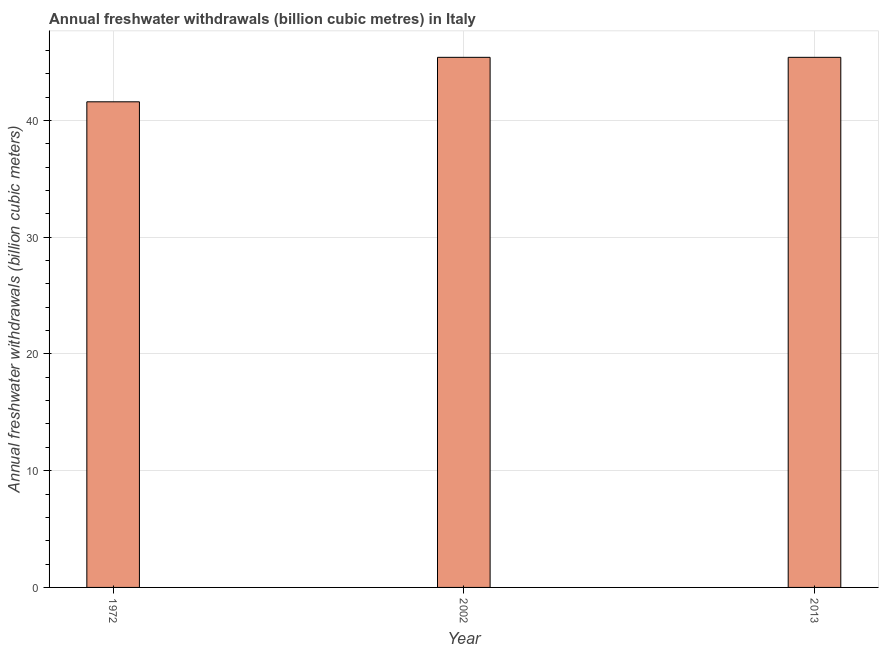What is the title of the graph?
Give a very brief answer. Annual freshwater withdrawals (billion cubic metres) in Italy. What is the label or title of the Y-axis?
Give a very brief answer. Annual freshwater withdrawals (billion cubic meters). What is the annual freshwater withdrawals in 1972?
Ensure brevity in your answer.  41.6. Across all years, what is the maximum annual freshwater withdrawals?
Offer a terse response. 45.41. Across all years, what is the minimum annual freshwater withdrawals?
Give a very brief answer. 41.6. What is the sum of the annual freshwater withdrawals?
Your response must be concise. 132.42. What is the difference between the annual freshwater withdrawals in 1972 and 2013?
Ensure brevity in your answer.  -3.81. What is the average annual freshwater withdrawals per year?
Your answer should be compact. 44.14. What is the median annual freshwater withdrawals?
Provide a succinct answer. 45.41. Do a majority of the years between 2002 and 1972 (inclusive) have annual freshwater withdrawals greater than 30 billion cubic meters?
Ensure brevity in your answer.  No. What is the ratio of the annual freshwater withdrawals in 1972 to that in 2002?
Your answer should be very brief. 0.92. Is the annual freshwater withdrawals in 2002 less than that in 2013?
Your answer should be very brief. No. Is the difference between the annual freshwater withdrawals in 1972 and 2002 greater than the difference between any two years?
Ensure brevity in your answer.  Yes. Is the sum of the annual freshwater withdrawals in 2002 and 2013 greater than the maximum annual freshwater withdrawals across all years?
Offer a very short reply. Yes. What is the difference between the highest and the lowest annual freshwater withdrawals?
Your response must be concise. 3.81. What is the Annual freshwater withdrawals (billion cubic meters) in 1972?
Your answer should be very brief. 41.6. What is the Annual freshwater withdrawals (billion cubic meters) in 2002?
Give a very brief answer. 45.41. What is the Annual freshwater withdrawals (billion cubic meters) of 2013?
Provide a succinct answer. 45.41. What is the difference between the Annual freshwater withdrawals (billion cubic meters) in 1972 and 2002?
Your response must be concise. -3.81. What is the difference between the Annual freshwater withdrawals (billion cubic meters) in 1972 and 2013?
Ensure brevity in your answer.  -3.81. What is the difference between the Annual freshwater withdrawals (billion cubic meters) in 2002 and 2013?
Give a very brief answer. 0. What is the ratio of the Annual freshwater withdrawals (billion cubic meters) in 1972 to that in 2002?
Give a very brief answer. 0.92. What is the ratio of the Annual freshwater withdrawals (billion cubic meters) in 1972 to that in 2013?
Ensure brevity in your answer.  0.92. 